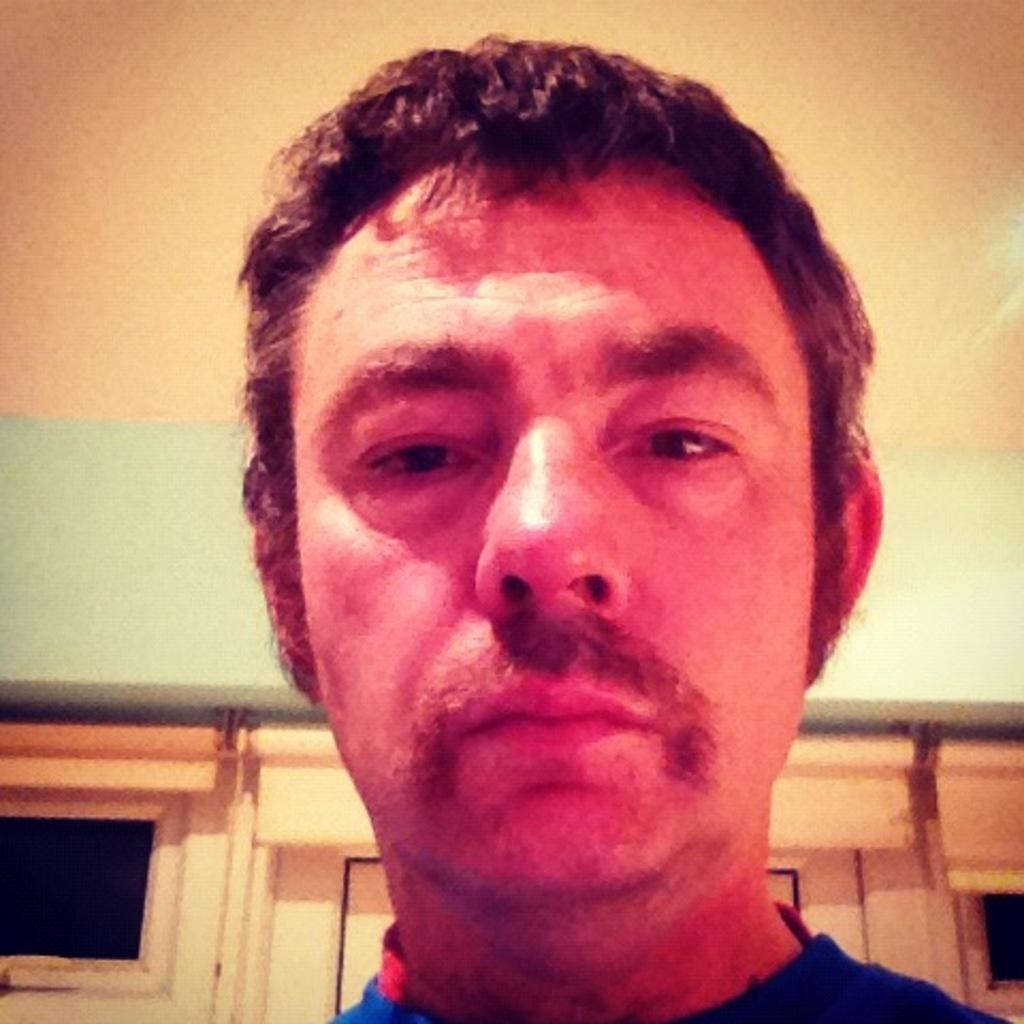Could you give a brief overview of what you see in this image? This image is taken indoors. At the top of the image there is a ceiling. In the background there is a wall with windows and a door. In the middle of the image there is a man. 